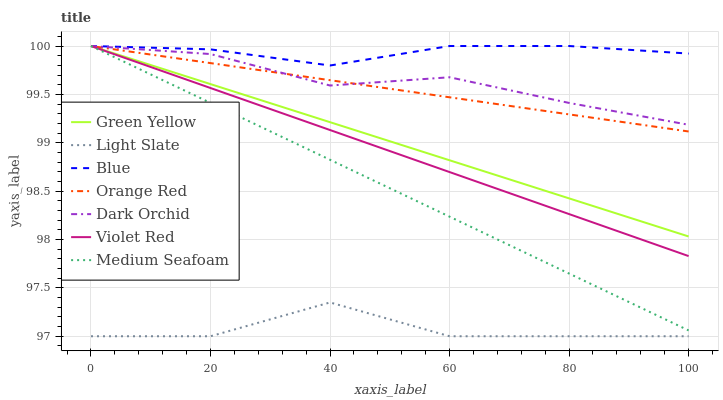Does Light Slate have the minimum area under the curve?
Answer yes or no. Yes. Does Blue have the maximum area under the curve?
Answer yes or no. Yes. Does Violet Red have the minimum area under the curve?
Answer yes or no. No. Does Violet Red have the maximum area under the curve?
Answer yes or no. No. Is Green Yellow the smoothest?
Answer yes or no. Yes. Is Light Slate the roughest?
Answer yes or no. Yes. Is Violet Red the smoothest?
Answer yes or no. No. Is Violet Red the roughest?
Answer yes or no. No. Does Light Slate have the lowest value?
Answer yes or no. Yes. Does Violet Red have the lowest value?
Answer yes or no. No. Does Orange Red have the highest value?
Answer yes or no. Yes. Does Light Slate have the highest value?
Answer yes or no. No. Is Light Slate less than Violet Red?
Answer yes or no. Yes. Is Orange Red greater than Light Slate?
Answer yes or no. Yes. Does Medium Seafoam intersect Green Yellow?
Answer yes or no. Yes. Is Medium Seafoam less than Green Yellow?
Answer yes or no. No. Is Medium Seafoam greater than Green Yellow?
Answer yes or no. No. Does Light Slate intersect Violet Red?
Answer yes or no. No. 